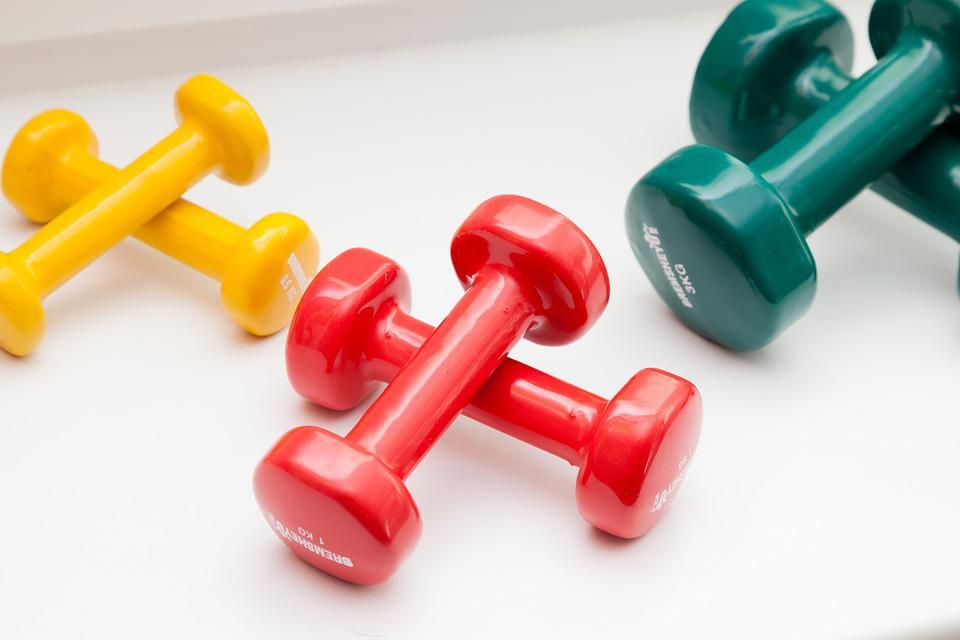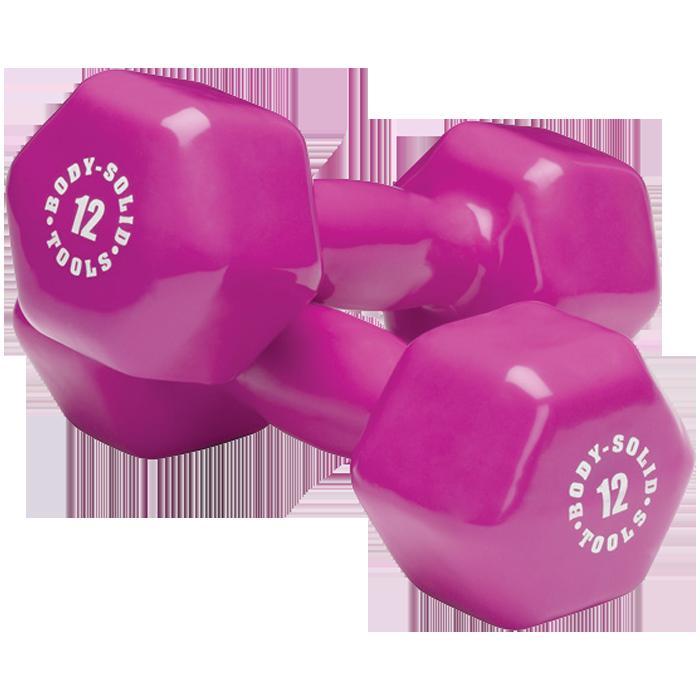The first image is the image on the left, the second image is the image on the right. Considering the images on both sides, is "There are no more than three weights in the image on the right." valid? Answer yes or no. Yes. The first image is the image on the left, the second image is the image on the right. Examine the images to the left and right. Is the description "An image shows a neat row of dumbbells arranged by weight that includes at least four different colored ends." accurate? Answer yes or no. No. 